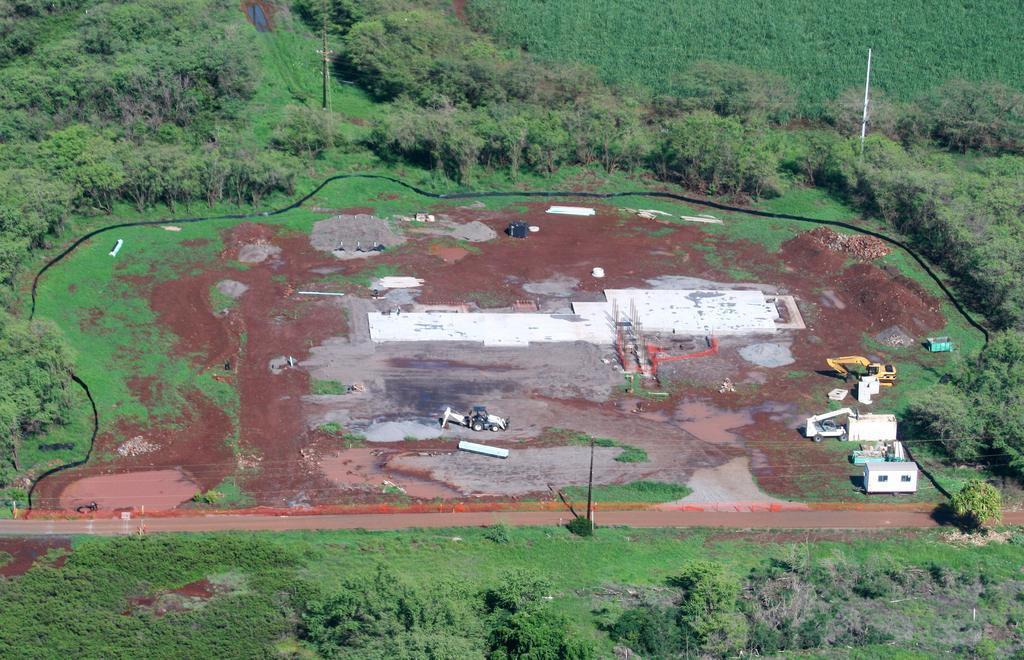Could you give a brief overview of what you see in this image? In this picture I can see vehicles, poles, cables and some other objects, and in the background there are trees. 